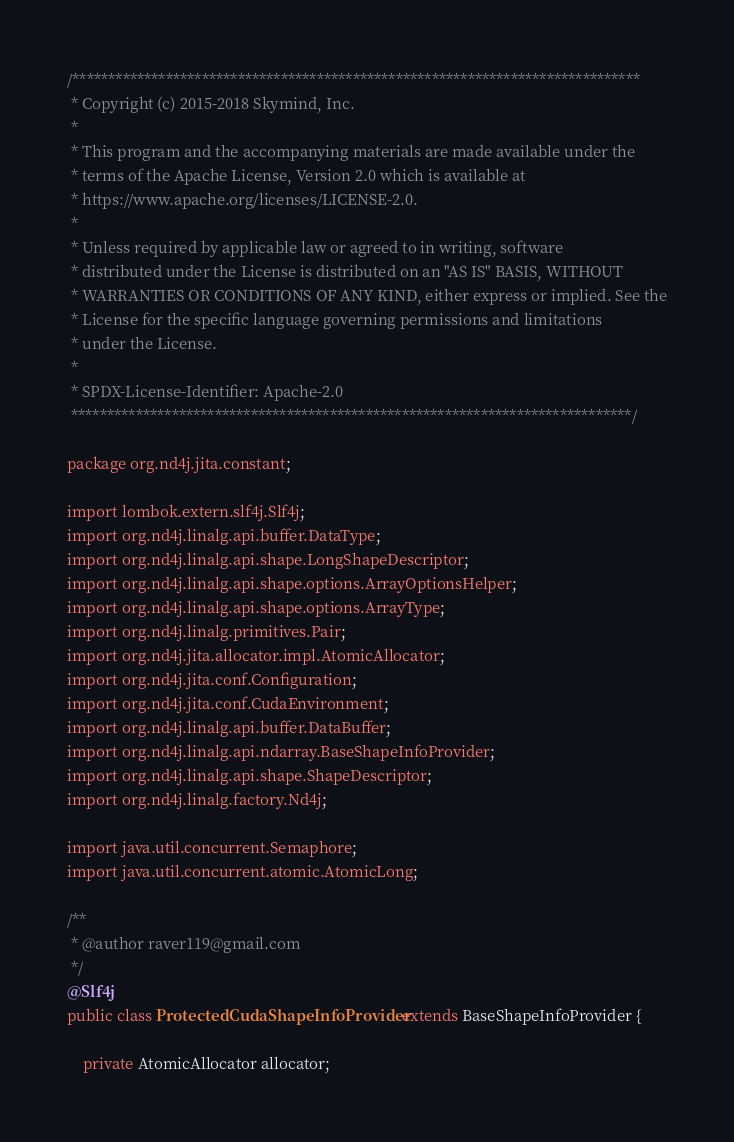Convert code to text. <code><loc_0><loc_0><loc_500><loc_500><_Java_>/*******************************************************************************
 * Copyright (c) 2015-2018 Skymind, Inc.
 *
 * This program and the accompanying materials are made available under the
 * terms of the Apache License, Version 2.0 which is available at
 * https://www.apache.org/licenses/LICENSE-2.0.
 *
 * Unless required by applicable law or agreed to in writing, software
 * distributed under the License is distributed on an "AS IS" BASIS, WITHOUT
 * WARRANTIES OR CONDITIONS OF ANY KIND, either express or implied. See the
 * License for the specific language governing permissions and limitations
 * under the License.
 *
 * SPDX-License-Identifier: Apache-2.0
 ******************************************************************************/

package org.nd4j.jita.constant;

import lombok.extern.slf4j.Slf4j;
import org.nd4j.linalg.api.buffer.DataType;
import org.nd4j.linalg.api.shape.LongShapeDescriptor;
import org.nd4j.linalg.api.shape.options.ArrayOptionsHelper;
import org.nd4j.linalg.api.shape.options.ArrayType;
import org.nd4j.linalg.primitives.Pair;
import org.nd4j.jita.allocator.impl.AtomicAllocator;
import org.nd4j.jita.conf.Configuration;
import org.nd4j.jita.conf.CudaEnvironment;
import org.nd4j.linalg.api.buffer.DataBuffer;
import org.nd4j.linalg.api.ndarray.BaseShapeInfoProvider;
import org.nd4j.linalg.api.shape.ShapeDescriptor;
import org.nd4j.linalg.factory.Nd4j;

import java.util.concurrent.Semaphore;
import java.util.concurrent.atomic.AtomicLong;

/**
 * @author raver119@gmail.com
 */
@Slf4j
public class ProtectedCudaShapeInfoProvider extends BaseShapeInfoProvider {

    private AtomicAllocator allocator;
</code> 